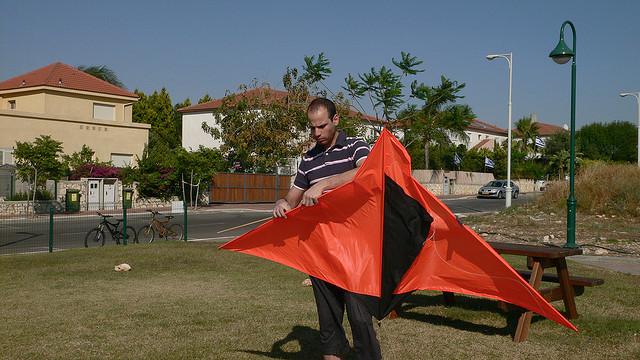Is it cloudy out?
Give a very brief answer. No. Is the sky blue and clear?
Keep it brief. Yes. What are these people holding?
Short answer required. Kite. What is the person holding?
Be succinct. Kite. Are the light poles the same color?
Be succinct. No. Is this a child or an adult in the photo?
Short answer required. Adult. Is this umbrella undamaged?
Short answer required. No. How is the weather in the picture?
Give a very brief answer. Sunny. What is the weather like?
Keep it brief. Sunny. How many bikes do you see?
Be succinct. 2. 